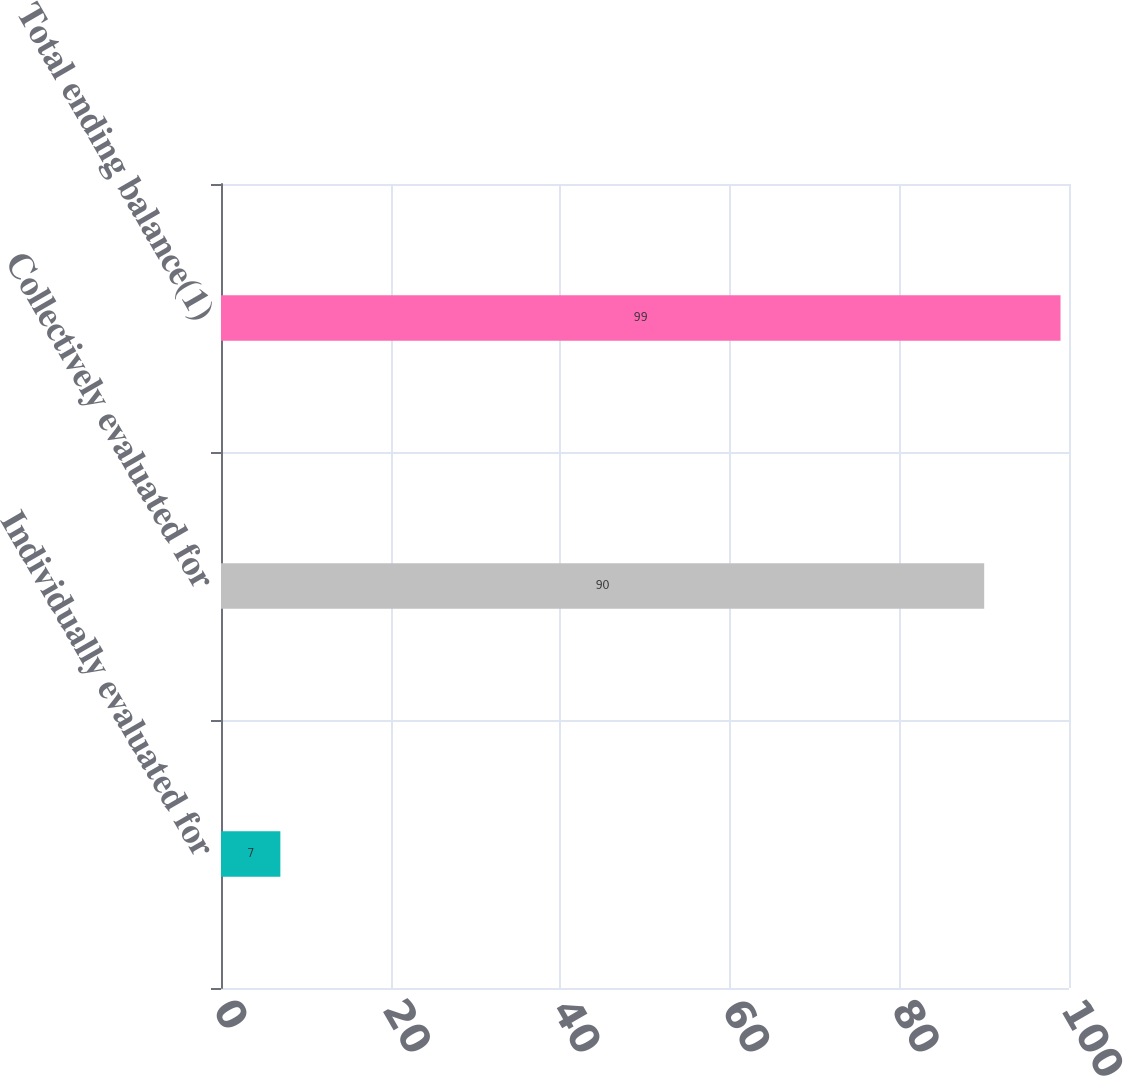<chart> <loc_0><loc_0><loc_500><loc_500><bar_chart><fcel>Individually evaluated for<fcel>Collectively evaluated for<fcel>Total ending balance(1)<nl><fcel>7<fcel>90<fcel>99<nl></chart> 